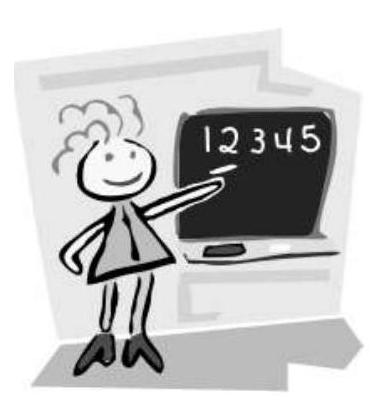Can you tell me more about what the image depicts? The image shows a simple cartoon of a person giving a presentation or teaching with numbers displayed on a blackboard. It appears to be aimed at illustrating concepts of counting or basic arithmetic. What might the numbers on the blackboard signify in an educational setting? In an educational context, the numbers on the blackboard likely serve as examples for teaching basic number recognition, counting skills, or perhaps introducing arithmetic operations. They're a tool to help students visualize and understand numerical concepts. 